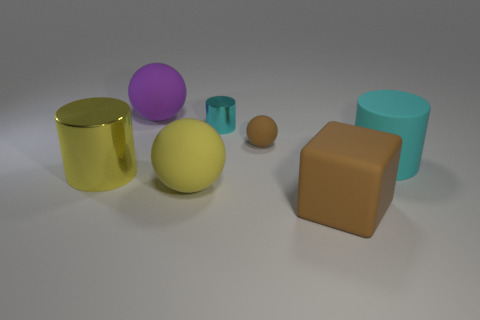What kind of lighting and shadows are present in the image? The lighting in the image is diffused, casting soft shadows beneath each object. The angle of the light source seems to be coming from above, as indicated by the direction of the shadows which all fall slightly to the right of each object. 